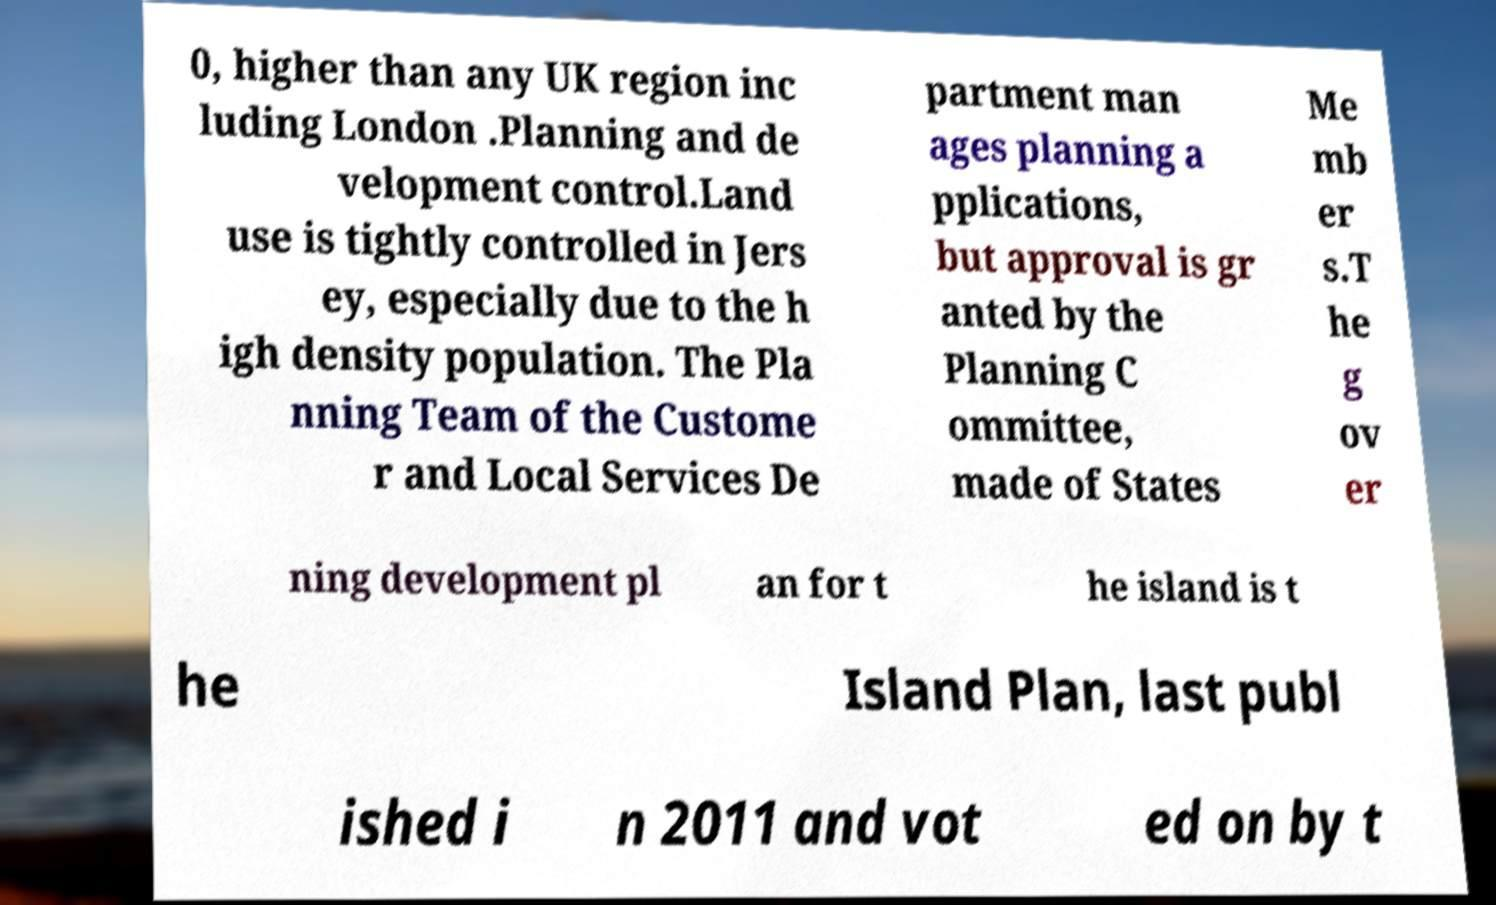I need the written content from this picture converted into text. Can you do that? 0, higher than any UK region inc luding London .Planning and de velopment control.Land use is tightly controlled in Jers ey, especially due to the h igh density population. The Pla nning Team of the Custome r and Local Services De partment man ages planning a pplications, but approval is gr anted by the Planning C ommittee, made of States Me mb er s.T he g ov er ning development pl an for t he island is t he Island Plan, last publ ished i n 2011 and vot ed on by t 